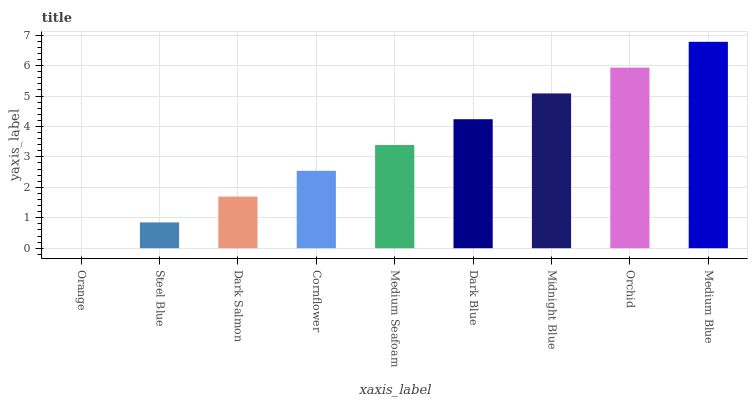Is Steel Blue the minimum?
Answer yes or no. No. Is Steel Blue the maximum?
Answer yes or no. No. Is Steel Blue greater than Orange?
Answer yes or no. Yes. Is Orange less than Steel Blue?
Answer yes or no. Yes. Is Orange greater than Steel Blue?
Answer yes or no. No. Is Steel Blue less than Orange?
Answer yes or no. No. Is Medium Seafoam the high median?
Answer yes or no. Yes. Is Medium Seafoam the low median?
Answer yes or no. Yes. Is Medium Blue the high median?
Answer yes or no. No. Is Cornflower the low median?
Answer yes or no. No. 